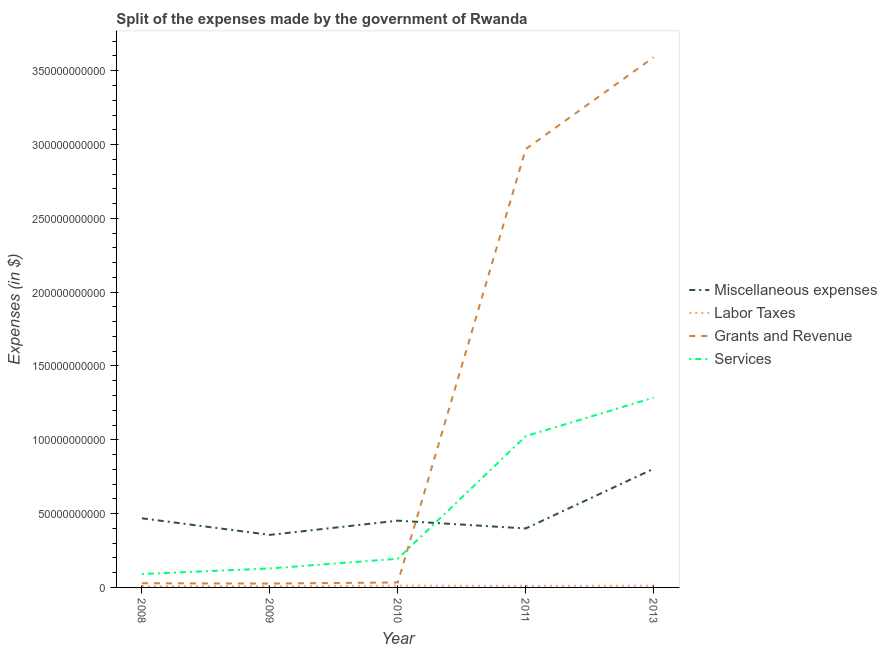How many different coloured lines are there?
Offer a terse response. 4. Does the line corresponding to amount spent on miscellaneous expenses intersect with the line corresponding to amount spent on services?
Provide a short and direct response. Yes. Is the number of lines equal to the number of legend labels?
Provide a succinct answer. Yes. What is the amount spent on labor taxes in 2009?
Offer a terse response. 9.60e+08. Across all years, what is the maximum amount spent on services?
Provide a short and direct response. 1.29e+11. Across all years, what is the minimum amount spent on services?
Your answer should be compact. 9.09e+09. In which year was the amount spent on labor taxes minimum?
Offer a very short reply. 2008. What is the total amount spent on services in the graph?
Offer a very short reply. 2.72e+11. What is the difference between the amount spent on labor taxes in 2009 and that in 2011?
Keep it short and to the point. -1.47e+08. What is the difference between the amount spent on miscellaneous expenses in 2011 and the amount spent on services in 2009?
Keep it short and to the point. 2.71e+1. What is the average amount spent on grants and revenue per year?
Make the answer very short. 1.33e+11. In the year 2008, what is the difference between the amount spent on services and amount spent on miscellaneous expenses?
Make the answer very short. -3.77e+1. What is the ratio of the amount spent on miscellaneous expenses in 2008 to that in 2013?
Offer a very short reply. 0.58. Is the amount spent on grants and revenue in 2009 less than that in 2011?
Ensure brevity in your answer.  Yes. Is the difference between the amount spent on grants and revenue in 2010 and 2013 greater than the difference between the amount spent on services in 2010 and 2013?
Make the answer very short. No. What is the difference between the highest and the second highest amount spent on grants and revenue?
Ensure brevity in your answer.  6.22e+1. What is the difference between the highest and the lowest amount spent on labor taxes?
Your response must be concise. 3.12e+08. In how many years, is the amount spent on grants and revenue greater than the average amount spent on grants and revenue taken over all years?
Ensure brevity in your answer.  2. Is the sum of the amount spent on labor taxes in 2009 and 2010 greater than the maximum amount spent on services across all years?
Your answer should be very brief. No. Is it the case that in every year, the sum of the amount spent on labor taxes and amount spent on miscellaneous expenses is greater than the sum of amount spent on services and amount spent on grants and revenue?
Your answer should be very brief. No. Is it the case that in every year, the sum of the amount spent on miscellaneous expenses and amount spent on labor taxes is greater than the amount spent on grants and revenue?
Your response must be concise. No. Does the amount spent on grants and revenue monotonically increase over the years?
Give a very brief answer. No. Is the amount spent on grants and revenue strictly greater than the amount spent on labor taxes over the years?
Provide a short and direct response. Yes. Is the amount spent on labor taxes strictly less than the amount spent on grants and revenue over the years?
Your answer should be compact. Yes. Are the values on the major ticks of Y-axis written in scientific E-notation?
Offer a terse response. No. Does the graph contain any zero values?
Your response must be concise. No. How are the legend labels stacked?
Give a very brief answer. Vertical. What is the title of the graph?
Offer a terse response. Split of the expenses made by the government of Rwanda. What is the label or title of the X-axis?
Provide a succinct answer. Year. What is the label or title of the Y-axis?
Offer a very short reply. Expenses (in $). What is the Expenses (in $) in Miscellaneous expenses in 2008?
Your answer should be compact. 4.68e+1. What is the Expenses (in $) of Labor Taxes in 2008?
Make the answer very short. 8.98e+08. What is the Expenses (in $) of Grants and Revenue in 2008?
Offer a very short reply. 2.83e+09. What is the Expenses (in $) in Services in 2008?
Your answer should be compact. 9.09e+09. What is the Expenses (in $) in Miscellaneous expenses in 2009?
Provide a succinct answer. 3.56e+1. What is the Expenses (in $) of Labor Taxes in 2009?
Offer a terse response. 9.60e+08. What is the Expenses (in $) of Grants and Revenue in 2009?
Keep it short and to the point. 2.63e+09. What is the Expenses (in $) in Services in 2009?
Your answer should be very brief. 1.28e+1. What is the Expenses (in $) of Miscellaneous expenses in 2010?
Your response must be concise. 4.52e+1. What is the Expenses (in $) of Labor Taxes in 2010?
Your answer should be compact. 1.21e+09. What is the Expenses (in $) of Grants and Revenue in 2010?
Make the answer very short. 3.37e+09. What is the Expenses (in $) in Services in 2010?
Keep it short and to the point. 1.94e+1. What is the Expenses (in $) in Miscellaneous expenses in 2011?
Your answer should be very brief. 3.99e+1. What is the Expenses (in $) in Labor Taxes in 2011?
Make the answer very short. 1.11e+09. What is the Expenses (in $) in Grants and Revenue in 2011?
Offer a very short reply. 2.97e+11. What is the Expenses (in $) in Services in 2011?
Provide a short and direct response. 1.02e+11. What is the Expenses (in $) of Miscellaneous expenses in 2013?
Ensure brevity in your answer.  8.04e+1. What is the Expenses (in $) of Labor Taxes in 2013?
Make the answer very short. 1.20e+09. What is the Expenses (in $) of Grants and Revenue in 2013?
Give a very brief answer. 3.59e+11. What is the Expenses (in $) in Services in 2013?
Keep it short and to the point. 1.29e+11. Across all years, what is the maximum Expenses (in $) in Miscellaneous expenses?
Ensure brevity in your answer.  8.04e+1. Across all years, what is the maximum Expenses (in $) in Labor Taxes?
Your answer should be compact. 1.21e+09. Across all years, what is the maximum Expenses (in $) in Grants and Revenue?
Your answer should be very brief. 3.59e+11. Across all years, what is the maximum Expenses (in $) of Services?
Your response must be concise. 1.29e+11. Across all years, what is the minimum Expenses (in $) in Miscellaneous expenses?
Provide a succinct answer. 3.56e+1. Across all years, what is the minimum Expenses (in $) of Labor Taxes?
Your answer should be very brief. 8.98e+08. Across all years, what is the minimum Expenses (in $) of Grants and Revenue?
Your answer should be very brief. 2.63e+09. Across all years, what is the minimum Expenses (in $) in Services?
Offer a very short reply. 9.09e+09. What is the total Expenses (in $) in Miscellaneous expenses in the graph?
Provide a short and direct response. 2.48e+11. What is the total Expenses (in $) of Labor Taxes in the graph?
Offer a terse response. 5.37e+09. What is the total Expenses (in $) of Grants and Revenue in the graph?
Your answer should be very brief. 6.65e+11. What is the total Expenses (in $) in Services in the graph?
Keep it short and to the point. 2.72e+11. What is the difference between the Expenses (in $) of Miscellaneous expenses in 2008 and that in 2009?
Ensure brevity in your answer.  1.12e+1. What is the difference between the Expenses (in $) of Labor Taxes in 2008 and that in 2009?
Offer a terse response. -6.20e+07. What is the difference between the Expenses (in $) in Grants and Revenue in 2008 and that in 2009?
Offer a very short reply. 2.04e+08. What is the difference between the Expenses (in $) in Services in 2008 and that in 2009?
Ensure brevity in your answer.  -3.76e+09. What is the difference between the Expenses (in $) in Miscellaneous expenses in 2008 and that in 2010?
Your answer should be compact. 1.60e+09. What is the difference between the Expenses (in $) in Labor Taxes in 2008 and that in 2010?
Your answer should be very brief. -3.12e+08. What is the difference between the Expenses (in $) in Grants and Revenue in 2008 and that in 2010?
Keep it short and to the point. -5.35e+08. What is the difference between the Expenses (in $) of Services in 2008 and that in 2010?
Offer a terse response. -1.03e+1. What is the difference between the Expenses (in $) of Miscellaneous expenses in 2008 and that in 2011?
Your answer should be compact. 6.88e+09. What is the difference between the Expenses (in $) in Labor Taxes in 2008 and that in 2011?
Provide a succinct answer. -2.09e+08. What is the difference between the Expenses (in $) in Grants and Revenue in 2008 and that in 2011?
Provide a succinct answer. -2.94e+11. What is the difference between the Expenses (in $) of Services in 2008 and that in 2011?
Make the answer very short. -9.34e+1. What is the difference between the Expenses (in $) of Miscellaneous expenses in 2008 and that in 2013?
Your answer should be compact. -3.36e+1. What is the difference between the Expenses (in $) of Labor Taxes in 2008 and that in 2013?
Offer a very short reply. -2.97e+08. What is the difference between the Expenses (in $) in Grants and Revenue in 2008 and that in 2013?
Your response must be concise. -3.56e+11. What is the difference between the Expenses (in $) in Services in 2008 and that in 2013?
Your answer should be very brief. -1.19e+11. What is the difference between the Expenses (in $) in Miscellaneous expenses in 2009 and that in 2010?
Your response must be concise. -9.63e+09. What is the difference between the Expenses (in $) in Labor Taxes in 2009 and that in 2010?
Give a very brief answer. -2.50e+08. What is the difference between the Expenses (in $) in Grants and Revenue in 2009 and that in 2010?
Make the answer very short. -7.39e+08. What is the difference between the Expenses (in $) in Services in 2009 and that in 2010?
Your response must be concise. -6.56e+09. What is the difference between the Expenses (in $) of Miscellaneous expenses in 2009 and that in 2011?
Provide a short and direct response. -4.34e+09. What is the difference between the Expenses (in $) in Labor Taxes in 2009 and that in 2011?
Keep it short and to the point. -1.47e+08. What is the difference between the Expenses (in $) in Grants and Revenue in 2009 and that in 2011?
Offer a terse response. -2.94e+11. What is the difference between the Expenses (in $) in Services in 2009 and that in 2011?
Offer a terse response. -8.96e+1. What is the difference between the Expenses (in $) in Miscellaneous expenses in 2009 and that in 2013?
Give a very brief answer. -4.48e+1. What is the difference between the Expenses (in $) of Labor Taxes in 2009 and that in 2013?
Keep it short and to the point. -2.35e+08. What is the difference between the Expenses (in $) of Grants and Revenue in 2009 and that in 2013?
Ensure brevity in your answer.  -3.57e+11. What is the difference between the Expenses (in $) in Services in 2009 and that in 2013?
Make the answer very short. -1.16e+11. What is the difference between the Expenses (in $) in Miscellaneous expenses in 2010 and that in 2011?
Ensure brevity in your answer.  5.29e+09. What is the difference between the Expenses (in $) in Labor Taxes in 2010 and that in 2011?
Your answer should be compact. 1.03e+08. What is the difference between the Expenses (in $) of Grants and Revenue in 2010 and that in 2011?
Offer a very short reply. -2.94e+11. What is the difference between the Expenses (in $) in Services in 2010 and that in 2011?
Your answer should be very brief. -8.30e+1. What is the difference between the Expenses (in $) in Miscellaneous expenses in 2010 and that in 2013?
Provide a succinct answer. -3.52e+1. What is the difference between the Expenses (in $) of Labor Taxes in 2010 and that in 2013?
Your response must be concise. 1.46e+07. What is the difference between the Expenses (in $) in Grants and Revenue in 2010 and that in 2013?
Offer a very short reply. -3.56e+11. What is the difference between the Expenses (in $) of Services in 2010 and that in 2013?
Provide a short and direct response. -1.09e+11. What is the difference between the Expenses (in $) in Miscellaneous expenses in 2011 and that in 2013?
Provide a succinct answer. -4.05e+1. What is the difference between the Expenses (in $) in Labor Taxes in 2011 and that in 2013?
Give a very brief answer. -8.79e+07. What is the difference between the Expenses (in $) in Grants and Revenue in 2011 and that in 2013?
Offer a very short reply. -6.22e+1. What is the difference between the Expenses (in $) in Services in 2011 and that in 2013?
Ensure brevity in your answer.  -2.61e+1. What is the difference between the Expenses (in $) of Miscellaneous expenses in 2008 and the Expenses (in $) of Labor Taxes in 2009?
Provide a short and direct response. 4.59e+1. What is the difference between the Expenses (in $) in Miscellaneous expenses in 2008 and the Expenses (in $) in Grants and Revenue in 2009?
Provide a short and direct response. 4.42e+1. What is the difference between the Expenses (in $) of Miscellaneous expenses in 2008 and the Expenses (in $) of Services in 2009?
Make the answer very short. 3.40e+1. What is the difference between the Expenses (in $) of Labor Taxes in 2008 and the Expenses (in $) of Grants and Revenue in 2009?
Your answer should be very brief. -1.73e+09. What is the difference between the Expenses (in $) in Labor Taxes in 2008 and the Expenses (in $) in Services in 2009?
Offer a very short reply. -1.20e+1. What is the difference between the Expenses (in $) in Grants and Revenue in 2008 and the Expenses (in $) in Services in 2009?
Keep it short and to the point. -1.00e+1. What is the difference between the Expenses (in $) of Miscellaneous expenses in 2008 and the Expenses (in $) of Labor Taxes in 2010?
Provide a short and direct response. 4.56e+1. What is the difference between the Expenses (in $) in Miscellaneous expenses in 2008 and the Expenses (in $) in Grants and Revenue in 2010?
Ensure brevity in your answer.  4.35e+1. What is the difference between the Expenses (in $) of Miscellaneous expenses in 2008 and the Expenses (in $) of Services in 2010?
Ensure brevity in your answer.  2.74e+1. What is the difference between the Expenses (in $) in Labor Taxes in 2008 and the Expenses (in $) in Grants and Revenue in 2010?
Your answer should be compact. -2.47e+09. What is the difference between the Expenses (in $) in Labor Taxes in 2008 and the Expenses (in $) in Services in 2010?
Your answer should be very brief. -1.85e+1. What is the difference between the Expenses (in $) in Grants and Revenue in 2008 and the Expenses (in $) in Services in 2010?
Keep it short and to the point. -1.66e+1. What is the difference between the Expenses (in $) in Miscellaneous expenses in 2008 and the Expenses (in $) in Labor Taxes in 2011?
Ensure brevity in your answer.  4.57e+1. What is the difference between the Expenses (in $) in Miscellaneous expenses in 2008 and the Expenses (in $) in Grants and Revenue in 2011?
Your answer should be very brief. -2.50e+11. What is the difference between the Expenses (in $) of Miscellaneous expenses in 2008 and the Expenses (in $) of Services in 2011?
Make the answer very short. -5.56e+1. What is the difference between the Expenses (in $) in Labor Taxes in 2008 and the Expenses (in $) in Grants and Revenue in 2011?
Ensure brevity in your answer.  -2.96e+11. What is the difference between the Expenses (in $) in Labor Taxes in 2008 and the Expenses (in $) in Services in 2011?
Give a very brief answer. -1.02e+11. What is the difference between the Expenses (in $) in Grants and Revenue in 2008 and the Expenses (in $) in Services in 2011?
Ensure brevity in your answer.  -9.96e+1. What is the difference between the Expenses (in $) in Miscellaneous expenses in 2008 and the Expenses (in $) in Labor Taxes in 2013?
Give a very brief answer. 4.56e+1. What is the difference between the Expenses (in $) in Miscellaneous expenses in 2008 and the Expenses (in $) in Grants and Revenue in 2013?
Your response must be concise. -3.12e+11. What is the difference between the Expenses (in $) of Miscellaneous expenses in 2008 and the Expenses (in $) of Services in 2013?
Provide a short and direct response. -8.18e+1. What is the difference between the Expenses (in $) of Labor Taxes in 2008 and the Expenses (in $) of Grants and Revenue in 2013?
Give a very brief answer. -3.58e+11. What is the difference between the Expenses (in $) of Labor Taxes in 2008 and the Expenses (in $) of Services in 2013?
Give a very brief answer. -1.28e+11. What is the difference between the Expenses (in $) of Grants and Revenue in 2008 and the Expenses (in $) of Services in 2013?
Offer a terse response. -1.26e+11. What is the difference between the Expenses (in $) of Miscellaneous expenses in 2009 and the Expenses (in $) of Labor Taxes in 2010?
Ensure brevity in your answer.  3.44e+1. What is the difference between the Expenses (in $) in Miscellaneous expenses in 2009 and the Expenses (in $) in Grants and Revenue in 2010?
Ensure brevity in your answer.  3.22e+1. What is the difference between the Expenses (in $) in Miscellaneous expenses in 2009 and the Expenses (in $) in Services in 2010?
Give a very brief answer. 1.62e+1. What is the difference between the Expenses (in $) in Labor Taxes in 2009 and the Expenses (in $) in Grants and Revenue in 2010?
Ensure brevity in your answer.  -2.41e+09. What is the difference between the Expenses (in $) of Labor Taxes in 2009 and the Expenses (in $) of Services in 2010?
Give a very brief answer. -1.85e+1. What is the difference between the Expenses (in $) of Grants and Revenue in 2009 and the Expenses (in $) of Services in 2010?
Keep it short and to the point. -1.68e+1. What is the difference between the Expenses (in $) of Miscellaneous expenses in 2009 and the Expenses (in $) of Labor Taxes in 2011?
Keep it short and to the point. 3.45e+1. What is the difference between the Expenses (in $) of Miscellaneous expenses in 2009 and the Expenses (in $) of Grants and Revenue in 2011?
Make the answer very short. -2.61e+11. What is the difference between the Expenses (in $) in Miscellaneous expenses in 2009 and the Expenses (in $) in Services in 2011?
Make the answer very short. -6.69e+1. What is the difference between the Expenses (in $) of Labor Taxes in 2009 and the Expenses (in $) of Grants and Revenue in 2011?
Keep it short and to the point. -2.96e+11. What is the difference between the Expenses (in $) of Labor Taxes in 2009 and the Expenses (in $) of Services in 2011?
Keep it short and to the point. -1.02e+11. What is the difference between the Expenses (in $) in Grants and Revenue in 2009 and the Expenses (in $) in Services in 2011?
Offer a very short reply. -9.98e+1. What is the difference between the Expenses (in $) in Miscellaneous expenses in 2009 and the Expenses (in $) in Labor Taxes in 2013?
Your answer should be compact. 3.44e+1. What is the difference between the Expenses (in $) in Miscellaneous expenses in 2009 and the Expenses (in $) in Grants and Revenue in 2013?
Provide a succinct answer. -3.24e+11. What is the difference between the Expenses (in $) in Miscellaneous expenses in 2009 and the Expenses (in $) in Services in 2013?
Provide a short and direct response. -9.30e+1. What is the difference between the Expenses (in $) in Labor Taxes in 2009 and the Expenses (in $) in Grants and Revenue in 2013?
Make the answer very short. -3.58e+11. What is the difference between the Expenses (in $) of Labor Taxes in 2009 and the Expenses (in $) of Services in 2013?
Make the answer very short. -1.28e+11. What is the difference between the Expenses (in $) in Grants and Revenue in 2009 and the Expenses (in $) in Services in 2013?
Make the answer very short. -1.26e+11. What is the difference between the Expenses (in $) of Miscellaneous expenses in 2010 and the Expenses (in $) of Labor Taxes in 2011?
Provide a short and direct response. 4.41e+1. What is the difference between the Expenses (in $) of Miscellaneous expenses in 2010 and the Expenses (in $) of Grants and Revenue in 2011?
Keep it short and to the point. -2.52e+11. What is the difference between the Expenses (in $) in Miscellaneous expenses in 2010 and the Expenses (in $) in Services in 2011?
Provide a succinct answer. -5.72e+1. What is the difference between the Expenses (in $) of Labor Taxes in 2010 and the Expenses (in $) of Grants and Revenue in 2011?
Make the answer very short. -2.96e+11. What is the difference between the Expenses (in $) in Labor Taxes in 2010 and the Expenses (in $) in Services in 2011?
Make the answer very short. -1.01e+11. What is the difference between the Expenses (in $) of Grants and Revenue in 2010 and the Expenses (in $) of Services in 2011?
Offer a terse response. -9.91e+1. What is the difference between the Expenses (in $) of Miscellaneous expenses in 2010 and the Expenses (in $) of Labor Taxes in 2013?
Provide a succinct answer. 4.40e+1. What is the difference between the Expenses (in $) in Miscellaneous expenses in 2010 and the Expenses (in $) in Grants and Revenue in 2013?
Ensure brevity in your answer.  -3.14e+11. What is the difference between the Expenses (in $) in Miscellaneous expenses in 2010 and the Expenses (in $) in Services in 2013?
Ensure brevity in your answer.  -8.33e+1. What is the difference between the Expenses (in $) in Labor Taxes in 2010 and the Expenses (in $) in Grants and Revenue in 2013?
Offer a very short reply. -3.58e+11. What is the difference between the Expenses (in $) of Labor Taxes in 2010 and the Expenses (in $) of Services in 2013?
Provide a short and direct response. -1.27e+11. What is the difference between the Expenses (in $) of Grants and Revenue in 2010 and the Expenses (in $) of Services in 2013?
Your response must be concise. -1.25e+11. What is the difference between the Expenses (in $) in Miscellaneous expenses in 2011 and the Expenses (in $) in Labor Taxes in 2013?
Your answer should be very brief. 3.87e+1. What is the difference between the Expenses (in $) of Miscellaneous expenses in 2011 and the Expenses (in $) of Grants and Revenue in 2013?
Offer a terse response. -3.19e+11. What is the difference between the Expenses (in $) in Miscellaneous expenses in 2011 and the Expenses (in $) in Services in 2013?
Your response must be concise. -8.86e+1. What is the difference between the Expenses (in $) of Labor Taxes in 2011 and the Expenses (in $) of Grants and Revenue in 2013?
Your answer should be compact. -3.58e+11. What is the difference between the Expenses (in $) of Labor Taxes in 2011 and the Expenses (in $) of Services in 2013?
Your answer should be compact. -1.27e+11. What is the difference between the Expenses (in $) of Grants and Revenue in 2011 and the Expenses (in $) of Services in 2013?
Provide a short and direct response. 1.68e+11. What is the average Expenses (in $) of Miscellaneous expenses per year?
Offer a terse response. 4.96e+1. What is the average Expenses (in $) of Labor Taxes per year?
Your answer should be compact. 1.07e+09. What is the average Expenses (in $) in Grants and Revenue per year?
Give a very brief answer. 1.33e+11. What is the average Expenses (in $) in Services per year?
Your response must be concise. 5.45e+1. In the year 2008, what is the difference between the Expenses (in $) of Miscellaneous expenses and Expenses (in $) of Labor Taxes?
Provide a short and direct response. 4.59e+1. In the year 2008, what is the difference between the Expenses (in $) in Miscellaneous expenses and Expenses (in $) in Grants and Revenue?
Your answer should be very brief. 4.40e+1. In the year 2008, what is the difference between the Expenses (in $) of Miscellaneous expenses and Expenses (in $) of Services?
Your response must be concise. 3.77e+1. In the year 2008, what is the difference between the Expenses (in $) in Labor Taxes and Expenses (in $) in Grants and Revenue?
Offer a very short reply. -1.94e+09. In the year 2008, what is the difference between the Expenses (in $) in Labor Taxes and Expenses (in $) in Services?
Your answer should be very brief. -8.19e+09. In the year 2008, what is the difference between the Expenses (in $) of Grants and Revenue and Expenses (in $) of Services?
Ensure brevity in your answer.  -6.26e+09. In the year 2009, what is the difference between the Expenses (in $) of Miscellaneous expenses and Expenses (in $) of Labor Taxes?
Give a very brief answer. 3.46e+1. In the year 2009, what is the difference between the Expenses (in $) of Miscellaneous expenses and Expenses (in $) of Grants and Revenue?
Make the answer very short. 3.30e+1. In the year 2009, what is the difference between the Expenses (in $) of Miscellaneous expenses and Expenses (in $) of Services?
Your response must be concise. 2.27e+1. In the year 2009, what is the difference between the Expenses (in $) of Labor Taxes and Expenses (in $) of Grants and Revenue?
Give a very brief answer. -1.67e+09. In the year 2009, what is the difference between the Expenses (in $) in Labor Taxes and Expenses (in $) in Services?
Your answer should be very brief. -1.19e+1. In the year 2009, what is the difference between the Expenses (in $) in Grants and Revenue and Expenses (in $) in Services?
Provide a succinct answer. -1.02e+1. In the year 2010, what is the difference between the Expenses (in $) in Miscellaneous expenses and Expenses (in $) in Labor Taxes?
Your answer should be compact. 4.40e+1. In the year 2010, what is the difference between the Expenses (in $) in Miscellaneous expenses and Expenses (in $) in Grants and Revenue?
Your answer should be very brief. 4.19e+1. In the year 2010, what is the difference between the Expenses (in $) of Miscellaneous expenses and Expenses (in $) of Services?
Offer a terse response. 2.58e+1. In the year 2010, what is the difference between the Expenses (in $) in Labor Taxes and Expenses (in $) in Grants and Revenue?
Provide a short and direct response. -2.16e+09. In the year 2010, what is the difference between the Expenses (in $) of Labor Taxes and Expenses (in $) of Services?
Ensure brevity in your answer.  -1.82e+1. In the year 2010, what is the difference between the Expenses (in $) in Grants and Revenue and Expenses (in $) in Services?
Ensure brevity in your answer.  -1.60e+1. In the year 2011, what is the difference between the Expenses (in $) of Miscellaneous expenses and Expenses (in $) of Labor Taxes?
Ensure brevity in your answer.  3.88e+1. In the year 2011, what is the difference between the Expenses (in $) of Miscellaneous expenses and Expenses (in $) of Grants and Revenue?
Ensure brevity in your answer.  -2.57e+11. In the year 2011, what is the difference between the Expenses (in $) in Miscellaneous expenses and Expenses (in $) in Services?
Your response must be concise. -6.25e+1. In the year 2011, what is the difference between the Expenses (in $) in Labor Taxes and Expenses (in $) in Grants and Revenue?
Your answer should be compact. -2.96e+11. In the year 2011, what is the difference between the Expenses (in $) in Labor Taxes and Expenses (in $) in Services?
Make the answer very short. -1.01e+11. In the year 2011, what is the difference between the Expenses (in $) of Grants and Revenue and Expenses (in $) of Services?
Keep it short and to the point. 1.94e+11. In the year 2013, what is the difference between the Expenses (in $) of Miscellaneous expenses and Expenses (in $) of Labor Taxes?
Provide a succinct answer. 7.92e+1. In the year 2013, what is the difference between the Expenses (in $) in Miscellaneous expenses and Expenses (in $) in Grants and Revenue?
Offer a terse response. -2.79e+11. In the year 2013, what is the difference between the Expenses (in $) in Miscellaneous expenses and Expenses (in $) in Services?
Ensure brevity in your answer.  -4.82e+1. In the year 2013, what is the difference between the Expenses (in $) in Labor Taxes and Expenses (in $) in Grants and Revenue?
Your answer should be compact. -3.58e+11. In the year 2013, what is the difference between the Expenses (in $) of Labor Taxes and Expenses (in $) of Services?
Provide a short and direct response. -1.27e+11. In the year 2013, what is the difference between the Expenses (in $) of Grants and Revenue and Expenses (in $) of Services?
Offer a terse response. 2.31e+11. What is the ratio of the Expenses (in $) in Miscellaneous expenses in 2008 to that in 2009?
Give a very brief answer. 1.32. What is the ratio of the Expenses (in $) of Labor Taxes in 2008 to that in 2009?
Your answer should be compact. 0.94. What is the ratio of the Expenses (in $) in Grants and Revenue in 2008 to that in 2009?
Keep it short and to the point. 1.08. What is the ratio of the Expenses (in $) of Services in 2008 to that in 2009?
Give a very brief answer. 0.71. What is the ratio of the Expenses (in $) in Miscellaneous expenses in 2008 to that in 2010?
Make the answer very short. 1.04. What is the ratio of the Expenses (in $) of Labor Taxes in 2008 to that in 2010?
Provide a short and direct response. 0.74. What is the ratio of the Expenses (in $) of Grants and Revenue in 2008 to that in 2010?
Provide a succinct answer. 0.84. What is the ratio of the Expenses (in $) of Services in 2008 to that in 2010?
Your answer should be very brief. 0.47. What is the ratio of the Expenses (in $) of Miscellaneous expenses in 2008 to that in 2011?
Keep it short and to the point. 1.17. What is the ratio of the Expenses (in $) of Labor Taxes in 2008 to that in 2011?
Ensure brevity in your answer.  0.81. What is the ratio of the Expenses (in $) of Grants and Revenue in 2008 to that in 2011?
Your answer should be compact. 0.01. What is the ratio of the Expenses (in $) of Services in 2008 to that in 2011?
Offer a very short reply. 0.09. What is the ratio of the Expenses (in $) in Miscellaneous expenses in 2008 to that in 2013?
Your answer should be very brief. 0.58. What is the ratio of the Expenses (in $) of Labor Taxes in 2008 to that in 2013?
Your answer should be compact. 0.75. What is the ratio of the Expenses (in $) of Grants and Revenue in 2008 to that in 2013?
Make the answer very short. 0.01. What is the ratio of the Expenses (in $) of Services in 2008 to that in 2013?
Ensure brevity in your answer.  0.07. What is the ratio of the Expenses (in $) in Miscellaneous expenses in 2009 to that in 2010?
Offer a terse response. 0.79. What is the ratio of the Expenses (in $) of Labor Taxes in 2009 to that in 2010?
Ensure brevity in your answer.  0.79. What is the ratio of the Expenses (in $) in Grants and Revenue in 2009 to that in 2010?
Keep it short and to the point. 0.78. What is the ratio of the Expenses (in $) of Services in 2009 to that in 2010?
Provide a short and direct response. 0.66. What is the ratio of the Expenses (in $) of Miscellaneous expenses in 2009 to that in 2011?
Your answer should be compact. 0.89. What is the ratio of the Expenses (in $) of Labor Taxes in 2009 to that in 2011?
Make the answer very short. 0.87. What is the ratio of the Expenses (in $) of Grants and Revenue in 2009 to that in 2011?
Offer a very short reply. 0.01. What is the ratio of the Expenses (in $) of Services in 2009 to that in 2011?
Ensure brevity in your answer.  0.13. What is the ratio of the Expenses (in $) of Miscellaneous expenses in 2009 to that in 2013?
Your response must be concise. 0.44. What is the ratio of the Expenses (in $) of Labor Taxes in 2009 to that in 2013?
Your response must be concise. 0.8. What is the ratio of the Expenses (in $) in Grants and Revenue in 2009 to that in 2013?
Offer a terse response. 0.01. What is the ratio of the Expenses (in $) of Services in 2009 to that in 2013?
Offer a terse response. 0.1. What is the ratio of the Expenses (in $) in Miscellaneous expenses in 2010 to that in 2011?
Ensure brevity in your answer.  1.13. What is the ratio of the Expenses (in $) of Labor Taxes in 2010 to that in 2011?
Provide a succinct answer. 1.09. What is the ratio of the Expenses (in $) in Grants and Revenue in 2010 to that in 2011?
Offer a very short reply. 0.01. What is the ratio of the Expenses (in $) of Services in 2010 to that in 2011?
Your answer should be compact. 0.19. What is the ratio of the Expenses (in $) of Miscellaneous expenses in 2010 to that in 2013?
Your response must be concise. 0.56. What is the ratio of the Expenses (in $) in Labor Taxes in 2010 to that in 2013?
Your answer should be compact. 1.01. What is the ratio of the Expenses (in $) of Grants and Revenue in 2010 to that in 2013?
Your answer should be very brief. 0.01. What is the ratio of the Expenses (in $) in Services in 2010 to that in 2013?
Provide a short and direct response. 0.15. What is the ratio of the Expenses (in $) of Miscellaneous expenses in 2011 to that in 2013?
Offer a terse response. 0.5. What is the ratio of the Expenses (in $) of Labor Taxes in 2011 to that in 2013?
Offer a terse response. 0.93. What is the ratio of the Expenses (in $) in Grants and Revenue in 2011 to that in 2013?
Your answer should be compact. 0.83. What is the ratio of the Expenses (in $) of Services in 2011 to that in 2013?
Your answer should be very brief. 0.8. What is the difference between the highest and the second highest Expenses (in $) of Miscellaneous expenses?
Your answer should be compact. 3.36e+1. What is the difference between the highest and the second highest Expenses (in $) of Labor Taxes?
Keep it short and to the point. 1.46e+07. What is the difference between the highest and the second highest Expenses (in $) of Grants and Revenue?
Keep it short and to the point. 6.22e+1. What is the difference between the highest and the second highest Expenses (in $) in Services?
Your answer should be compact. 2.61e+1. What is the difference between the highest and the lowest Expenses (in $) of Miscellaneous expenses?
Offer a very short reply. 4.48e+1. What is the difference between the highest and the lowest Expenses (in $) in Labor Taxes?
Offer a very short reply. 3.12e+08. What is the difference between the highest and the lowest Expenses (in $) of Grants and Revenue?
Provide a short and direct response. 3.57e+11. What is the difference between the highest and the lowest Expenses (in $) in Services?
Offer a terse response. 1.19e+11. 